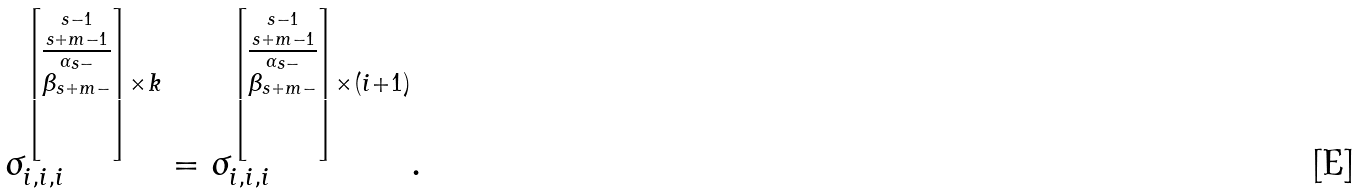Convert formula to latex. <formula><loc_0><loc_0><loc_500><loc_500>\sigma _ { i , i , i } ^ { \left [ \stackrel { s - 1 } { \stackrel { s + m - 1 } { \overline { \stackrel { \alpha _ { s - } } { \beta _ { s + m - } } } } } \right ] \times k } = \sigma _ { i , i , i } ^ { \left [ \stackrel { s - 1 } { \stackrel { s + m - 1 } { \overline { \stackrel { \alpha _ { s - } } { \beta _ { s + m - } } } } } \right ] \times ( i + 1 ) } .</formula> 